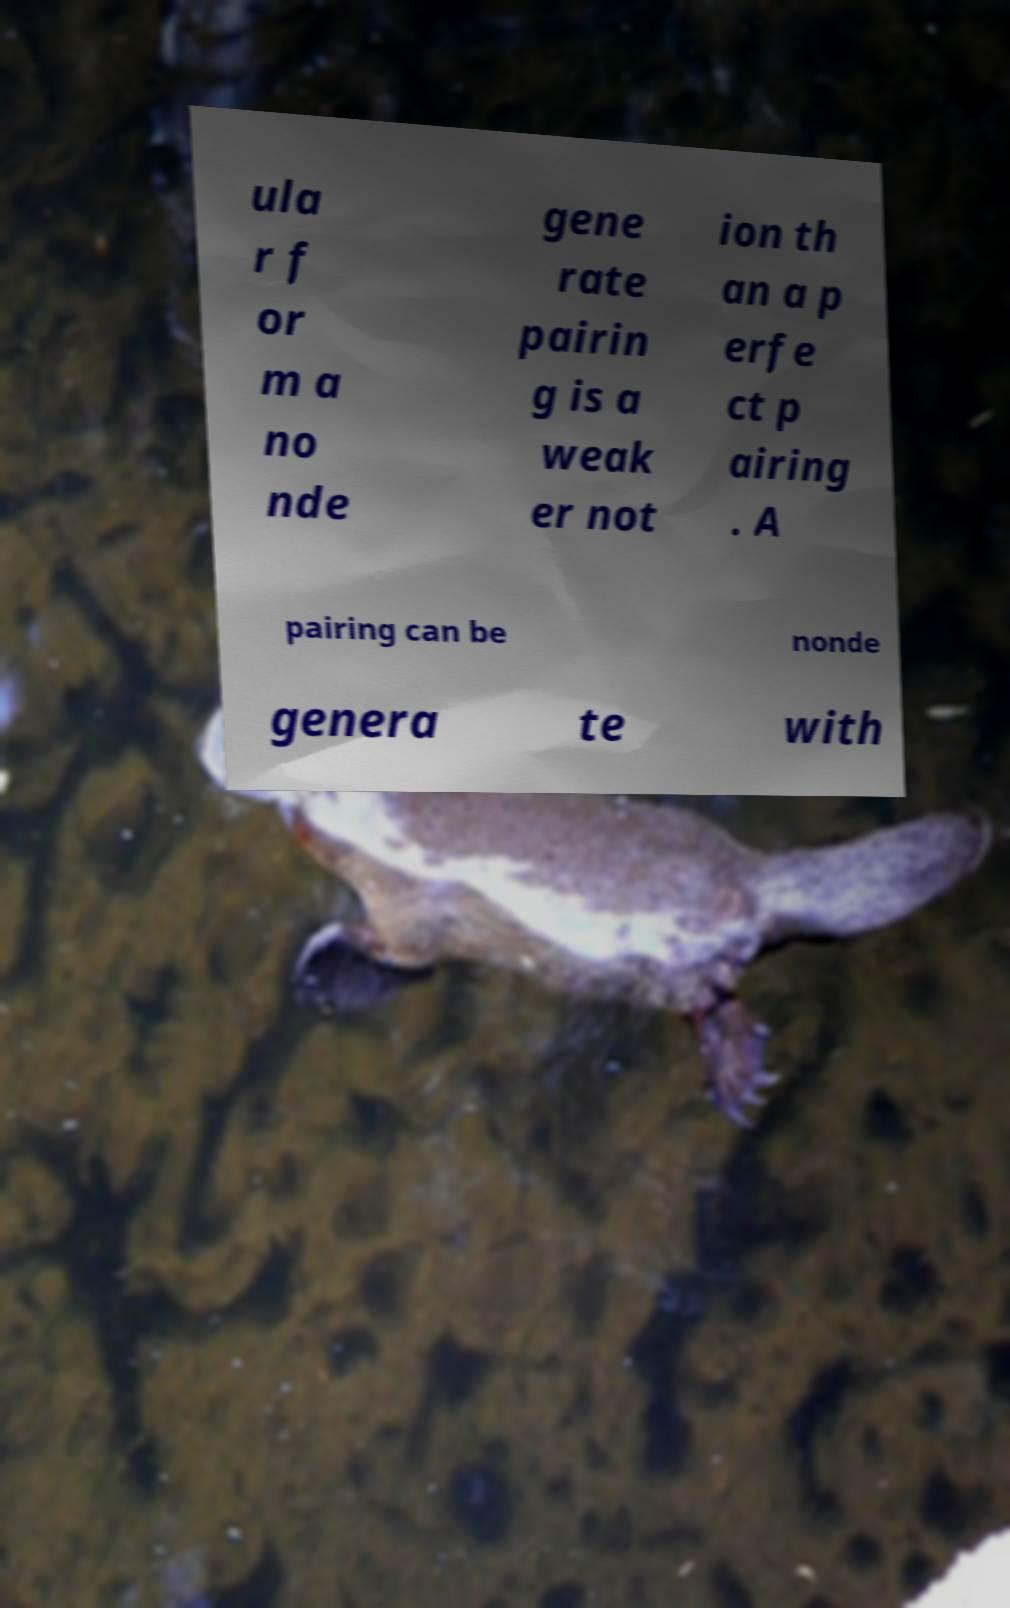What messages or text are displayed in this image? I need them in a readable, typed format. ula r f or m a no nde gene rate pairin g is a weak er not ion th an a p erfe ct p airing . A pairing can be nonde genera te with 